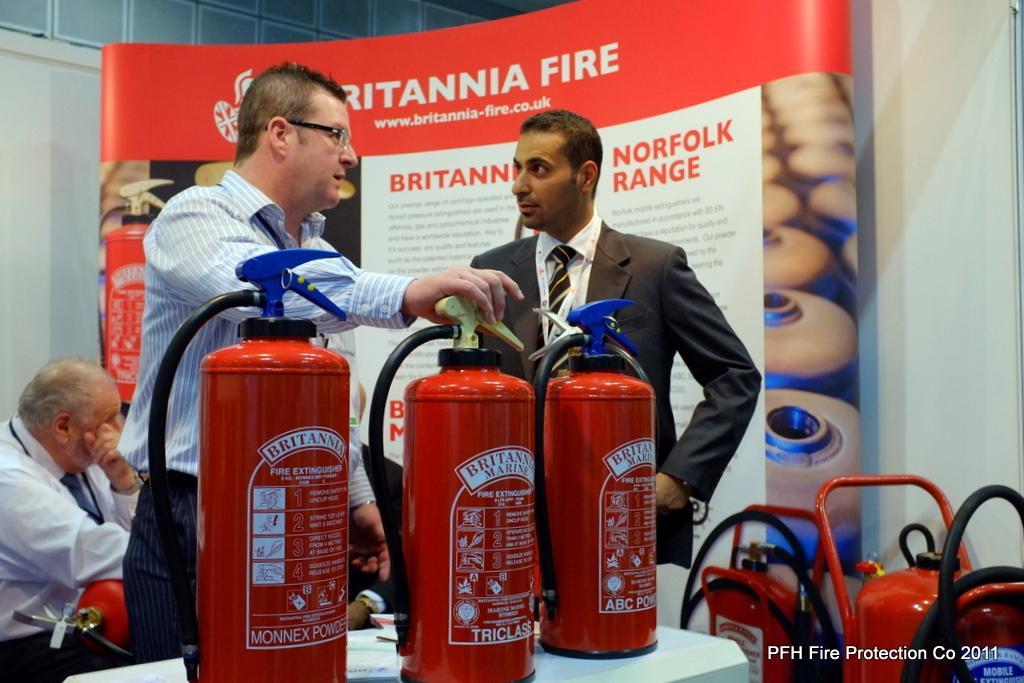Please provide a concise description of this image. At the bottom of the image there is a table on which there are fire extinguisher cylinders. Behind them there are two persons standing. In the background of the image there is a banner. There is a person sitting to the left side of the image. To the right side of the image there are cylinders and there is some text. 